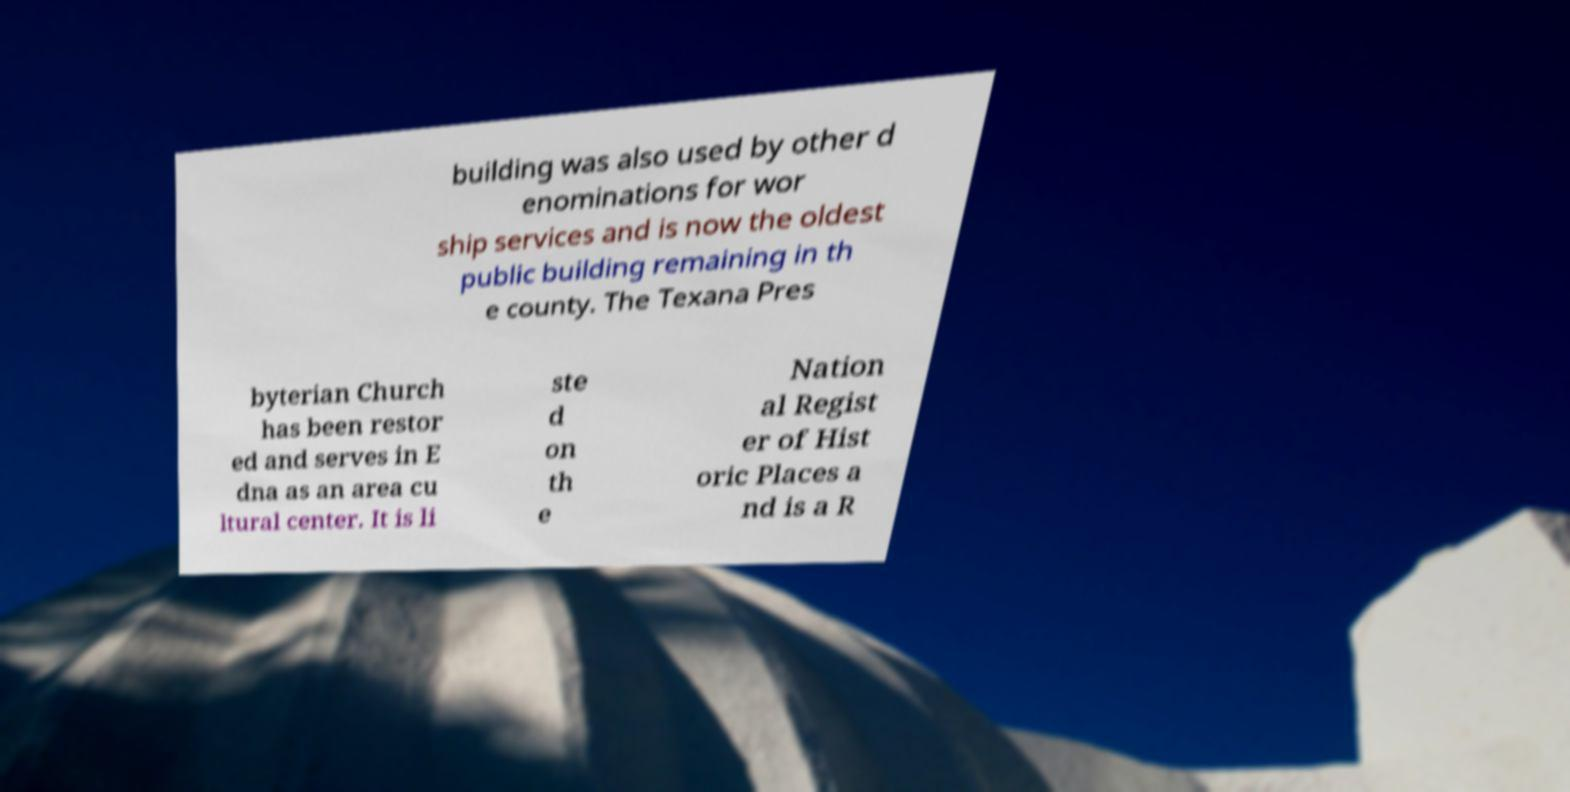Please identify and transcribe the text found in this image. building was also used by other d enominations for wor ship services and is now the oldest public building remaining in th e county. The Texana Pres byterian Church has been restor ed and serves in E dna as an area cu ltural center. It is li ste d on th e Nation al Regist er of Hist oric Places a nd is a R 